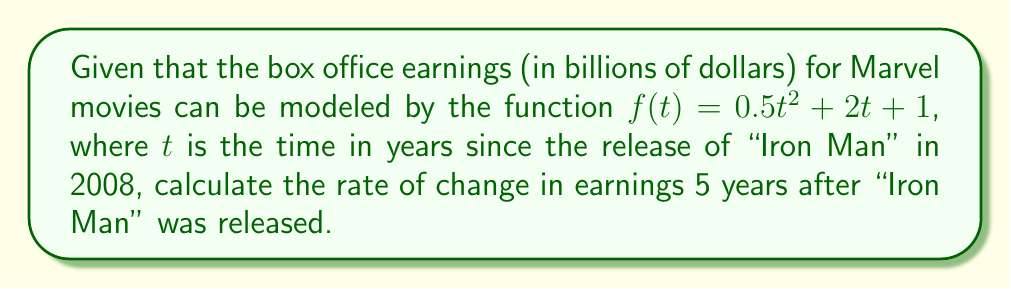Give your solution to this math problem. To find the rate of change in earnings, we need to calculate the derivative of the given function and evaluate it at $t = 5$.

Step 1: Find the derivative of $f(t)$.
$$f(t) = 0.5t^2 + 2t + 1$$
$$f'(t) = (0.5t^2)' + (2t)' + (1)'$$
$$f'(t) = t + 2 + 0$$
$$f'(t) = t + 2$$

Step 2: Evaluate $f'(t)$ at $t = 5$.
$$f'(5) = 5 + 2 = 7$$

Therefore, 5 years after the release of "Iron Man," the rate of change in box office earnings for Marvel movies was 7 billion dollars per year.
Answer: $7$ billion dollars per year 